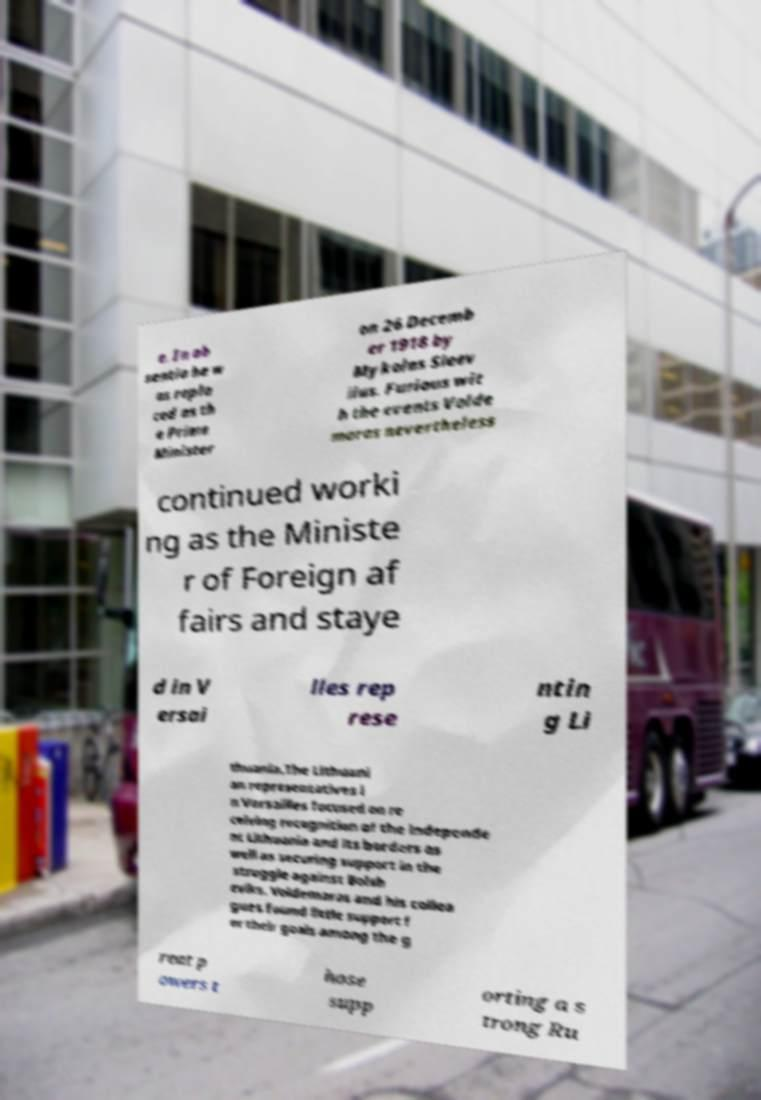Could you extract and type out the text from this image? e. In ab sentia he w as repla ced as th e Prime Minister on 26 Decemb er 1918 by Mykolas Sleev iius. Furious wit h the events Volde maras nevertheless continued worki ng as the Ministe r of Foreign af fairs and staye d in V ersai lles rep rese ntin g Li thuania.The Lithuani an representatives i n Versailles focused on re ceiving recognition of the independe nt Lithuania and its borders as well as securing support in the struggle against Bolsh eviks. Voldemaras and his collea gues found little support f or their goals among the g reat p owers t hose supp orting a s trong Ru 